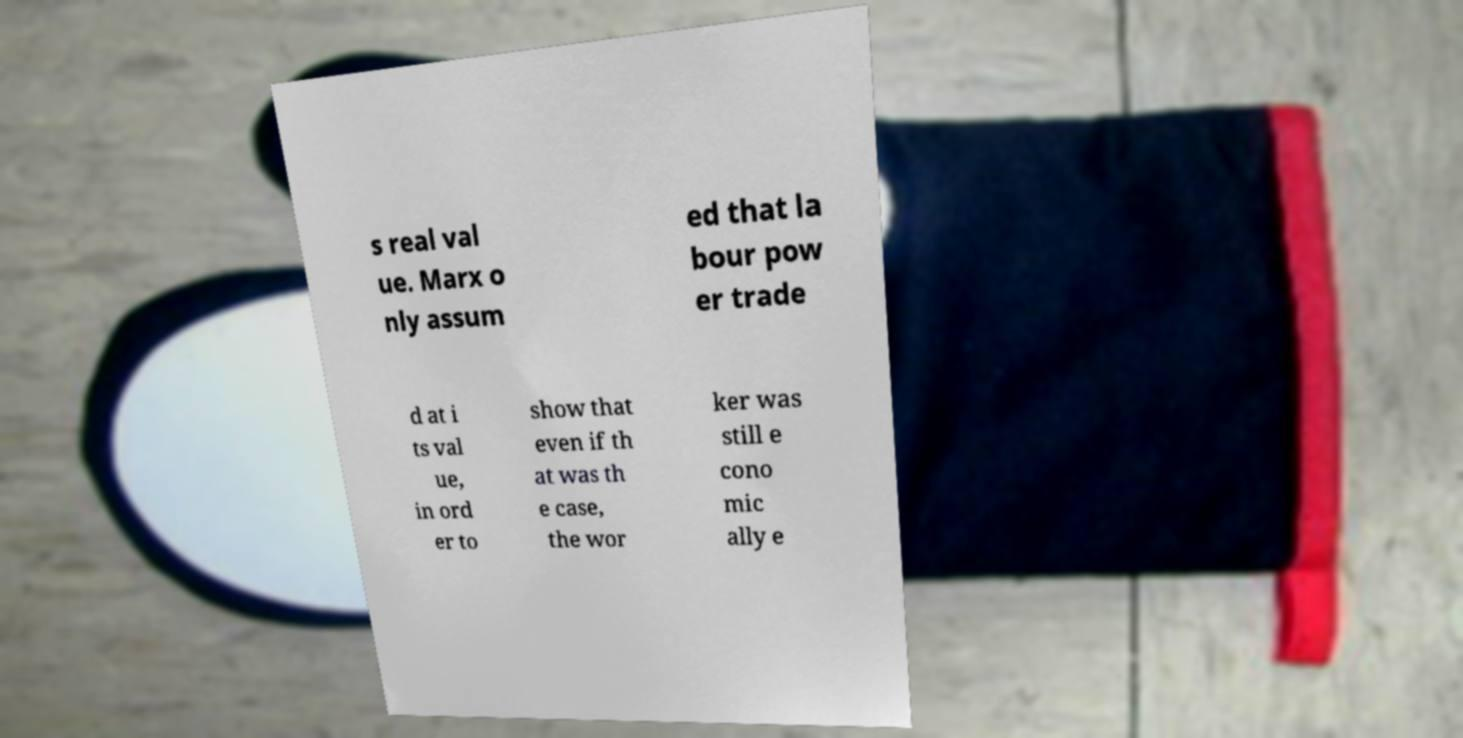What messages or text are displayed in this image? I need them in a readable, typed format. s real val ue. Marx o nly assum ed that la bour pow er trade d at i ts val ue, in ord er to show that even if th at was th e case, the wor ker was still e cono mic ally e 